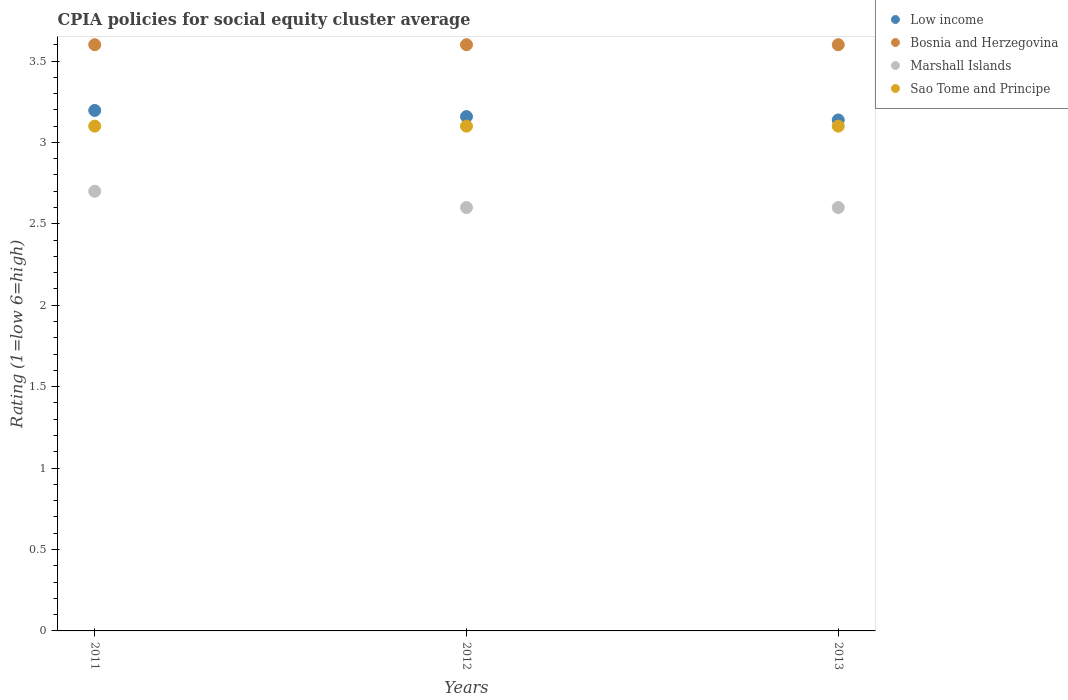Is the number of dotlines equal to the number of legend labels?
Ensure brevity in your answer.  Yes. What is the CPIA rating in Marshall Islands in 2013?
Give a very brief answer. 2.6. In which year was the CPIA rating in Low income maximum?
Offer a terse response. 2011. What is the total CPIA rating in Low income in the graph?
Keep it short and to the point. 9.49. What is the difference between the CPIA rating in Marshall Islands in 2011 and that in 2013?
Provide a succinct answer. 0.1. What is the average CPIA rating in Marshall Islands per year?
Make the answer very short. 2.63. In the year 2011, what is the difference between the CPIA rating in Bosnia and Herzegovina and CPIA rating in Low income?
Make the answer very short. 0.4. In how many years, is the CPIA rating in Sao Tome and Principe greater than 1.7?
Provide a succinct answer. 3. What is the ratio of the CPIA rating in Low income in 2011 to that in 2012?
Provide a succinct answer. 1.01. Is the difference between the CPIA rating in Bosnia and Herzegovina in 2011 and 2013 greater than the difference between the CPIA rating in Low income in 2011 and 2013?
Keep it short and to the point. No. In how many years, is the CPIA rating in Low income greater than the average CPIA rating in Low income taken over all years?
Offer a terse response. 1. Is it the case that in every year, the sum of the CPIA rating in Low income and CPIA rating in Marshall Islands  is greater than the sum of CPIA rating in Sao Tome and Principe and CPIA rating in Bosnia and Herzegovina?
Make the answer very short. No. Is it the case that in every year, the sum of the CPIA rating in Low income and CPIA rating in Marshall Islands  is greater than the CPIA rating in Bosnia and Herzegovina?
Give a very brief answer. Yes. Is the CPIA rating in Bosnia and Herzegovina strictly less than the CPIA rating in Marshall Islands over the years?
Your answer should be compact. No. How many dotlines are there?
Your answer should be compact. 4. Are the values on the major ticks of Y-axis written in scientific E-notation?
Offer a terse response. No. Does the graph contain any zero values?
Offer a very short reply. No. Does the graph contain grids?
Your response must be concise. No. Where does the legend appear in the graph?
Your answer should be compact. Top right. What is the title of the graph?
Offer a very short reply. CPIA policies for social equity cluster average. What is the Rating (1=low 6=high) of Low income in 2011?
Keep it short and to the point. 3.2. What is the Rating (1=low 6=high) of Marshall Islands in 2011?
Ensure brevity in your answer.  2.7. What is the Rating (1=low 6=high) of Sao Tome and Principe in 2011?
Your answer should be very brief. 3.1. What is the Rating (1=low 6=high) in Low income in 2012?
Keep it short and to the point. 3.16. What is the Rating (1=low 6=high) of Bosnia and Herzegovina in 2012?
Make the answer very short. 3.6. What is the Rating (1=low 6=high) of Sao Tome and Principe in 2012?
Provide a short and direct response. 3.1. What is the Rating (1=low 6=high) of Low income in 2013?
Your answer should be compact. 3.14. What is the Rating (1=low 6=high) in Bosnia and Herzegovina in 2013?
Your answer should be very brief. 3.6. What is the Rating (1=low 6=high) of Sao Tome and Principe in 2013?
Keep it short and to the point. 3.1. Across all years, what is the maximum Rating (1=low 6=high) in Low income?
Offer a very short reply. 3.2. Across all years, what is the maximum Rating (1=low 6=high) of Bosnia and Herzegovina?
Provide a succinct answer. 3.6. Across all years, what is the maximum Rating (1=low 6=high) in Sao Tome and Principe?
Make the answer very short. 3.1. Across all years, what is the minimum Rating (1=low 6=high) in Low income?
Your answer should be very brief. 3.14. Across all years, what is the minimum Rating (1=low 6=high) in Bosnia and Herzegovina?
Ensure brevity in your answer.  3.6. What is the total Rating (1=low 6=high) in Low income in the graph?
Your response must be concise. 9.49. What is the total Rating (1=low 6=high) of Bosnia and Herzegovina in the graph?
Your answer should be very brief. 10.8. What is the total Rating (1=low 6=high) of Marshall Islands in the graph?
Keep it short and to the point. 7.9. What is the difference between the Rating (1=low 6=high) in Low income in 2011 and that in 2012?
Your answer should be very brief. 0.04. What is the difference between the Rating (1=low 6=high) in Bosnia and Herzegovina in 2011 and that in 2012?
Give a very brief answer. 0. What is the difference between the Rating (1=low 6=high) in Marshall Islands in 2011 and that in 2012?
Ensure brevity in your answer.  0.1. What is the difference between the Rating (1=low 6=high) of Sao Tome and Principe in 2011 and that in 2012?
Your answer should be compact. 0. What is the difference between the Rating (1=low 6=high) in Low income in 2011 and that in 2013?
Your answer should be very brief. 0.06. What is the difference between the Rating (1=low 6=high) in Bosnia and Herzegovina in 2011 and that in 2013?
Give a very brief answer. 0. What is the difference between the Rating (1=low 6=high) of Low income in 2012 and that in 2013?
Ensure brevity in your answer.  0.02. What is the difference between the Rating (1=low 6=high) in Bosnia and Herzegovina in 2012 and that in 2013?
Your answer should be compact. 0. What is the difference between the Rating (1=low 6=high) of Low income in 2011 and the Rating (1=low 6=high) of Bosnia and Herzegovina in 2012?
Ensure brevity in your answer.  -0.4. What is the difference between the Rating (1=low 6=high) in Low income in 2011 and the Rating (1=low 6=high) in Marshall Islands in 2012?
Ensure brevity in your answer.  0.6. What is the difference between the Rating (1=low 6=high) in Low income in 2011 and the Rating (1=low 6=high) in Sao Tome and Principe in 2012?
Keep it short and to the point. 0.1. What is the difference between the Rating (1=low 6=high) of Bosnia and Herzegovina in 2011 and the Rating (1=low 6=high) of Marshall Islands in 2012?
Ensure brevity in your answer.  1. What is the difference between the Rating (1=low 6=high) in Bosnia and Herzegovina in 2011 and the Rating (1=low 6=high) in Sao Tome and Principe in 2012?
Provide a succinct answer. 0.5. What is the difference between the Rating (1=low 6=high) of Marshall Islands in 2011 and the Rating (1=low 6=high) of Sao Tome and Principe in 2012?
Your response must be concise. -0.4. What is the difference between the Rating (1=low 6=high) of Low income in 2011 and the Rating (1=low 6=high) of Bosnia and Herzegovina in 2013?
Provide a short and direct response. -0.4. What is the difference between the Rating (1=low 6=high) in Low income in 2011 and the Rating (1=low 6=high) in Marshall Islands in 2013?
Ensure brevity in your answer.  0.6. What is the difference between the Rating (1=low 6=high) in Low income in 2011 and the Rating (1=low 6=high) in Sao Tome and Principe in 2013?
Offer a terse response. 0.1. What is the difference between the Rating (1=low 6=high) in Marshall Islands in 2011 and the Rating (1=low 6=high) in Sao Tome and Principe in 2013?
Make the answer very short. -0.4. What is the difference between the Rating (1=low 6=high) of Low income in 2012 and the Rating (1=low 6=high) of Bosnia and Herzegovina in 2013?
Give a very brief answer. -0.44. What is the difference between the Rating (1=low 6=high) of Low income in 2012 and the Rating (1=low 6=high) of Marshall Islands in 2013?
Your answer should be very brief. 0.56. What is the difference between the Rating (1=low 6=high) of Low income in 2012 and the Rating (1=low 6=high) of Sao Tome and Principe in 2013?
Give a very brief answer. 0.06. What is the average Rating (1=low 6=high) in Low income per year?
Ensure brevity in your answer.  3.16. What is the average Rating (1=low 6=high) of Bosnia and Herzegovina per year?
Make the answer very short. 3.6. What is the average Rating (1=low 6=high) of Marshall Islands per year?
Provide a short and direct response. 2.63. In the year 2011, what is the difference between the Rating (1=low 6=high) of Low income and Rating (1=low 6=high) of Bosnia and Herzegovina?
Offer a terse response. -0.4. In the year 2011, what is the difference between the Rating (1=low 6=high) of Low income and Rating (1=low 6=high) of Marshall Islands?
Offer a very short reply. 0.5. In the year 2011, what is the difference between the Rating (1=low 6=high) in Low income and Rating (1=low 6=high) in Sao Tome and Principe?
Offer a very short reply. 0.1. In the year 2011, what is the difference between the Rating (1=low 6=high) of Bosnia and Herzegovina and Rating (1=low 6=high) of Marshall Islands?
Ensure brevity in your answer.  0.9. In the year 2011, what is the difference between the Rating (1=low 6=high) of Bosnia and Herzegovina and Rating (1=low 6=high) of Sao Tome and Principe?
Keep it short and to the point. 0.5. In the year 2011, what is the difference between the Rating (1=low 6=high) of Marshall Islands and Rating (1=low 6=high) of Sao Tome and Principe?
Your response must be concise. -0.4. In the year 2012, what is the difference between the Rating (1=low 6=high) in Low income and Rating (1=low 6=high) in Bosnia and Herzegovina?
Give a very brief answer. -0.44. In the year 2012, what is the difference between the Rating (1=low 6=high) in Low income and Rating (1=low 6=high) in Marshall Islands?
Your answer should be very brief. 0.56. In the year 2012, what is the difference between the Rating (1=low 6=high) in Low income and Rating (1=low 6=high) in Sao Tome and Principe?
Ensure brevity in your answer.  0.06. In the year 2013, what is the difference between the Rating (1=low 6=high) in Low income and Rating (1=low 6=high) in Bosnia and Herzegovina?
Offer a terse response. -0.46. In the year 2013, what is the difference between the Rating (1=low 6=high) of Low income and Rating (1=low 6=high) of Marshall Islands?
Your answer should be compact. 0.54. In the year 2013, what is the difference between the Rating (1=low 6=high) of Low income and Rating (1=low 6=high) of Sao Tome and Principe?
Provide a succinct answer. 0.04. In the year 2013, what is the difference between the Rating (1=low 6=high) in Bosnia and Herzegovina and Rating (1=low 6=high) in Marshall Islands?
Offer a very short reply. 1. What is the ratio of the Rating (1=low 6=high) in Low income in 2011 to that in 2012?
Ensure brevity in your answer.  1.01. What is the ratio of the Rating (1=low 6=high) of Low income in 2011 to that in 2013?
Offer a very short reply. 1.02. What is the ratio of the Rating (1=low 6=high) of Marshall Islands in 2011 to that in 2013?
Give a very brief answer. 1.04. What is the ratio of the Rating (1=low 6=high) of Low income in 2012 to that in 2013?
Offer a terse response. 1.01. What is the ratio of the Rating (1=low 6=high) of Bosnia and Herzegovina in 2012 to that in 2013?
Offer a terse response. 1. What is the ratio of the Rating (1=low 6=high) in Sao Tome and Principe in 2012 to that in 2013?
Your answer should be very brief. 1. What is the difference between the highest and the second highest Rating (1=low 6=high) of Low income?
Give a very brief answer. 0.04. What is the difference between the highest and the lowest Rating (1=low 6=high) in Low income?
Give a very brief answer. 0.06. What is the difference between the highest and the lowest Rating (1=low 6=high) of Marshall Islands?
Your response must be concise. 0.1. 